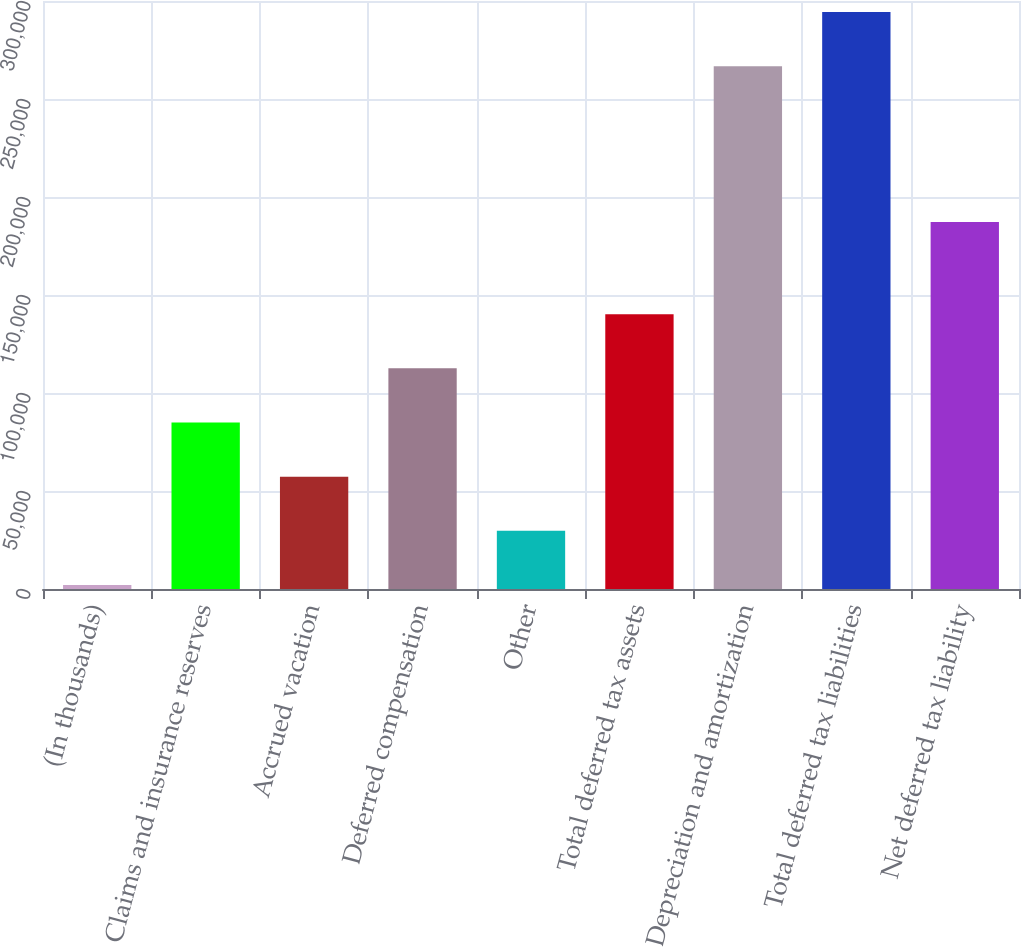<chart> <loc_0><loc_0><loc_500><loc_500><bar_chart><fcel>(In thousands)<fcel>Claims and insurance reserves<fcel>Accrued vacation<fcel>Deferred compensation<fcel>Other<fcel>Total deferred tax assets<fcel>Depreciation and amortization<fcel>Total deferred tax liabilities<fcel>Net deferred tax liability<nl><fcel>2017<fcel>84943.9<fcel>57301.6<fcel>112586<fcel>29659.3<fcel>140228<fcel>266730<fcel>294372<fcel>187223<nl></chart> 